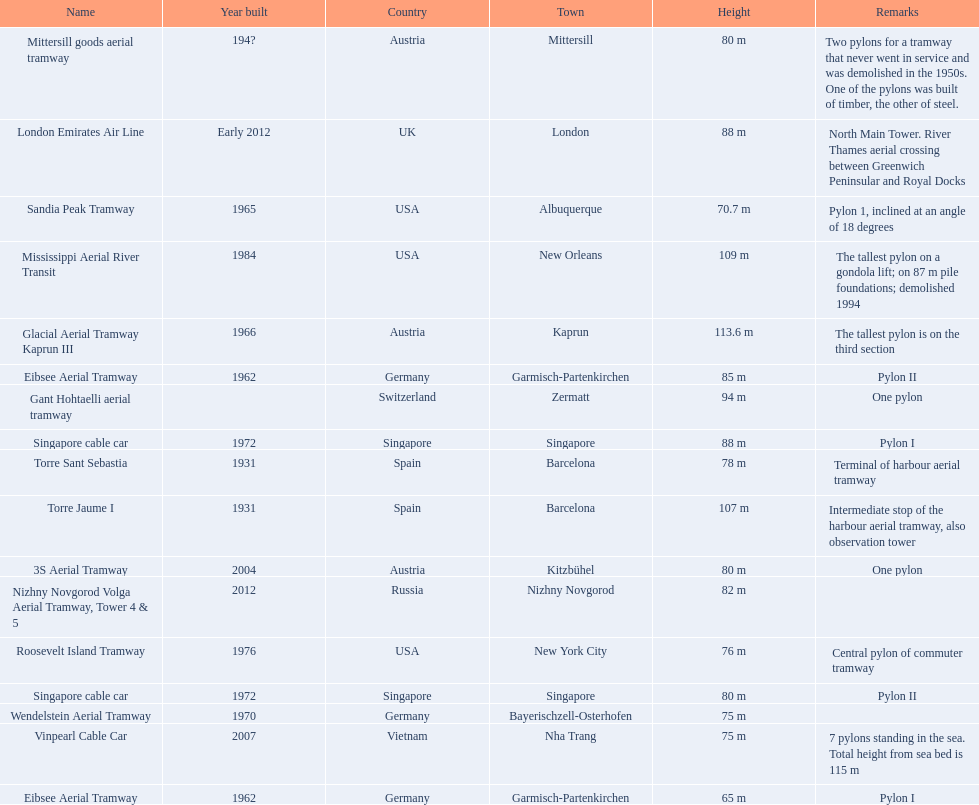Which aerial lifts are over 100 meters tall? Glacial Aerial Tramway Kaprun III, Mississippi Aerial River Transit, Torre Jaume I. Which of those was built last? Mississippi Aerial River Transit. And what is its total height? 109 m. 